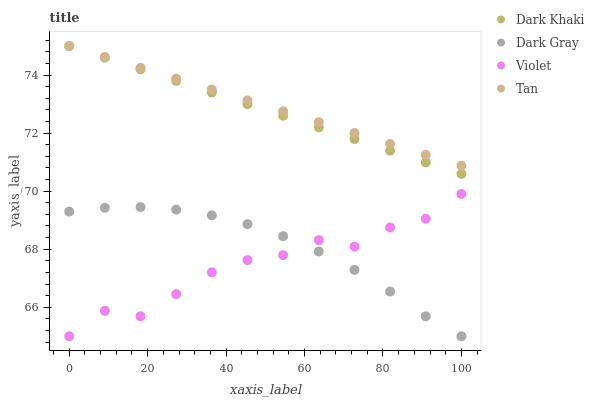Does Violet have the minimum area under the curve?
Answer yes or no. Yes. Does Tan have the maximum area under the curve?
Answer yes or no. Yes. Does Dark Gray have the minimum area under the curve?
Answer yes or no. No. Does Dark Gray have the maximum area under the curve?
Answer yes or no. No. Is Tan the smoothest?
Answer yes or no. Yes. Is Violet the roughest?
Answer yes or no. Yes. Is Dark Gray the smoothest?
Answer yes or no. No. Is Dark Gray the roughest?
Answer yes or no. No. Does Dark Gray have the lowest value?
Answer yes or no. Yes. Does Tan have the lowest value?
Answer yes or no. No. Does Tan have the highest value?
Answer yes or no. Yes. Does Dark Gray have the highest value?
Answer yes or no. No. Is Violet less than Tan?
Answer yes or no. Yes. Is Dark Khaki greater than Violet?
Answer yes or no. Yes. Does Tan intersect Dark Khaki?
Answer yes or no. Yes. Is Tan less than Dark Khaki?
Answer yes or no. No. Is Tan greater than Dark Khaki?
Answer yes or no. No. Does Violet intersect Tan?
Answer yes or no. No. 